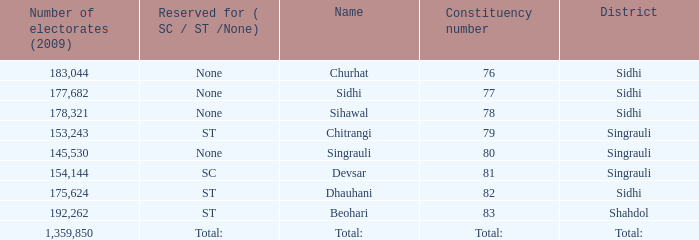Can you give me this table as a dict? {'header': ['Number of electorates (2009)', 'Reserved for ( SC / ST /None)', 'Name', 'Constituency number', 'District'], 'rows': [['183,044', 'None', 'Churhat', '76', 'Sidhi'], ['177,682', 'None', 'Sidhi', '77', 'Sidhi'], ['178,321', 'None', 'Sihawal', '78', 'Sidhi'], ['153,243', 'ST', 'Chitrangi', '79', 'Singrauli'], ['145,530', 'None', 'Singrauli', '80', 'Singrauli'], ['154,144', 'SC', 'Devsar', '81', 'Singrauli'], ['175,624', 'ST', 'Dhauhani', '82', 'Sidhi'], ['192,262', 'ST', 'Beohari', '83', 'Shahdol'], ['1,359,850', 'Total:', 'Total:', 'Total:', 'Total:']]} What is Beohari's reserved for (SC/ST/None)? ST. 